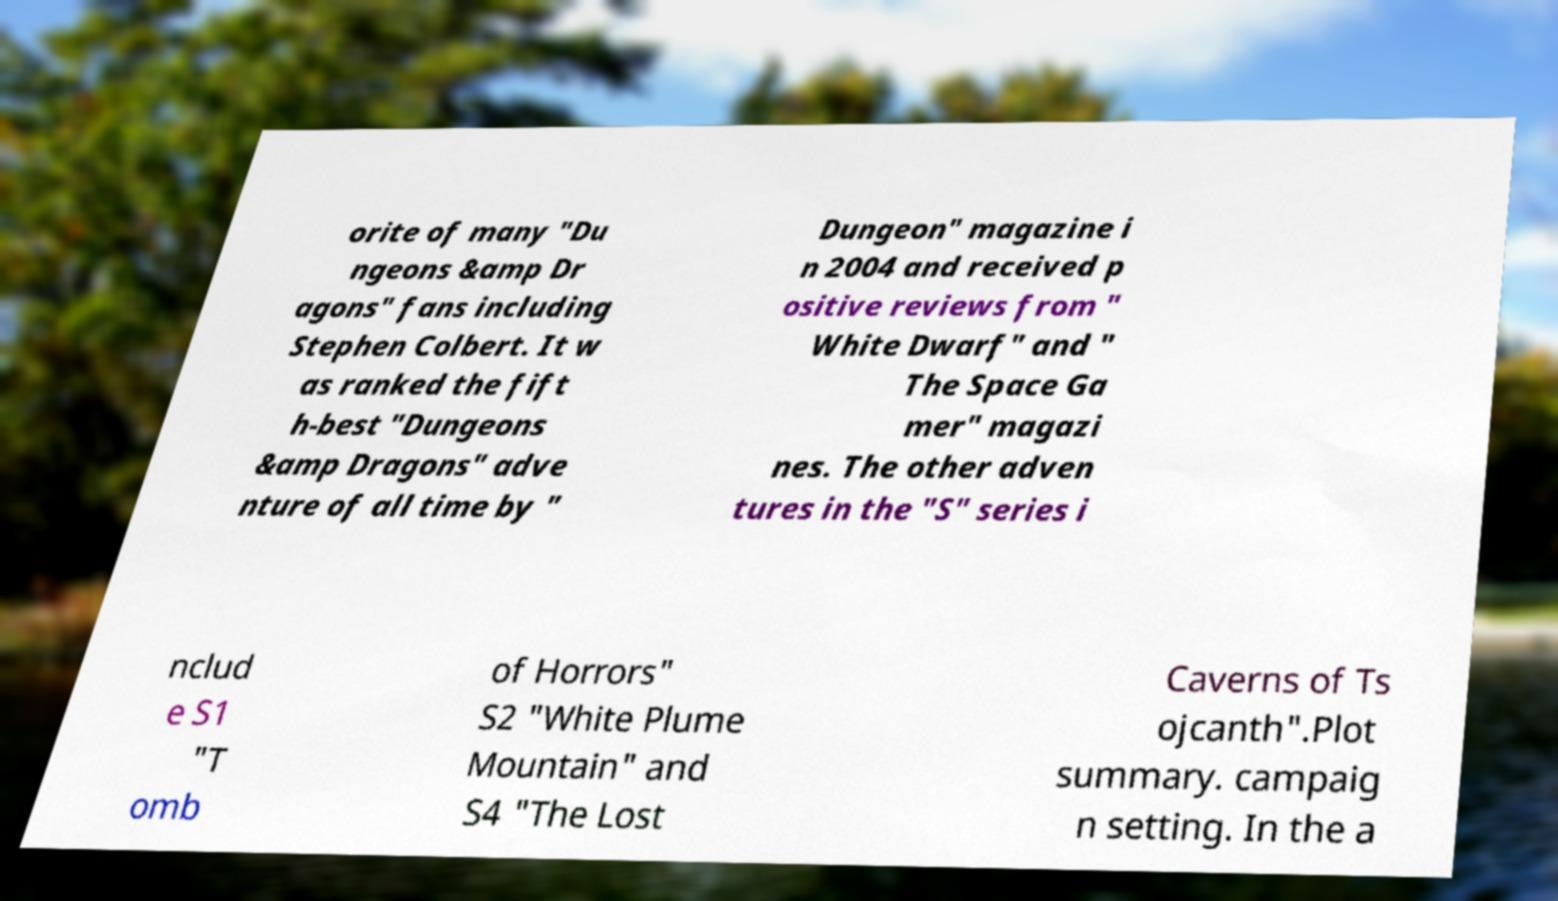There's text embedded in this image that I need extracted. Can you transcribe it verbatim? orite of many "Du ngeons &amp Dr agons" fans including Stephen Colbert. It w as ranked the fift h-best "Dungeons &amp Dragons" adve nture of all time by " Dungeon" magazine i n 2004 and received p ositive reviews from " White Dwarf" and " The Space Ga mer" magazi nes. The other adven tures in the "S" series i nclud e S1 "T omb of Horrors" S2 "White Plume Mountain" and S4 "The Lost Caverns of Ts ojcanth".Plot summary. campaig n setting. In the a 